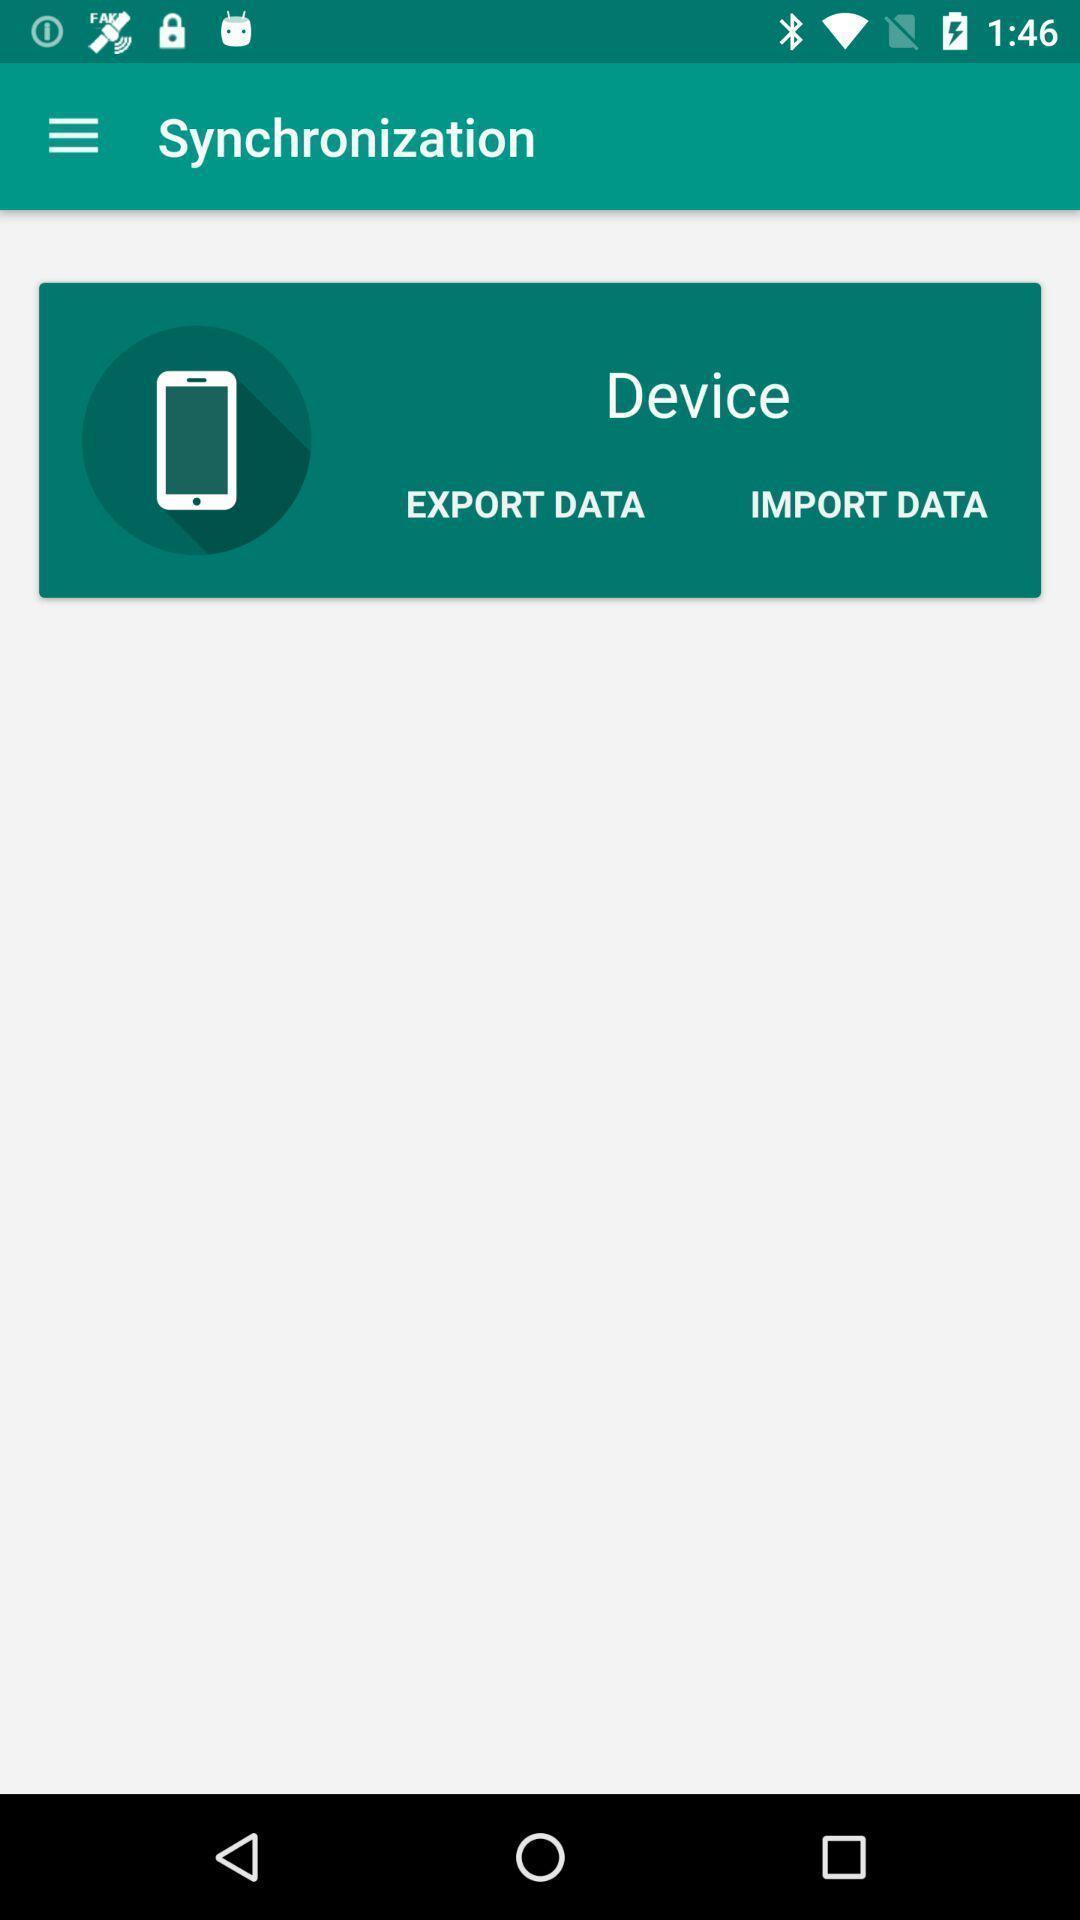What details can you identify in this image? Screen displaying to export and import data in device. 